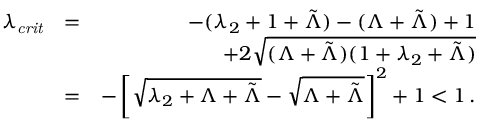<formula> <loc_0><loc_0><loc_500><loc_500>\begin{array} { r l r } { \lambda _ { c r i t } } & { = } & { - ( \lambda _ { 2 } + 1 + \tilde { \Lambda } ) - ( \Lambda + \tilde { \Lambda } ) + 1 } \\ & { + 2 \sqrt { ( \Lambda + \tilde { \Lambda } ) ( 1 + \lambda _ { 2 } + \tilde { \Lambda } ) } } \\ & { = } & { - \left [ \sqrt { \lambda _ { 2 } + \Lambda + \tilde { \Lambda } } - \sqrt { \Lambda + \tilde { \Lambda } } \right ] ^ { 2 } + 1 < 1 \, . } \end{array}</formula> 